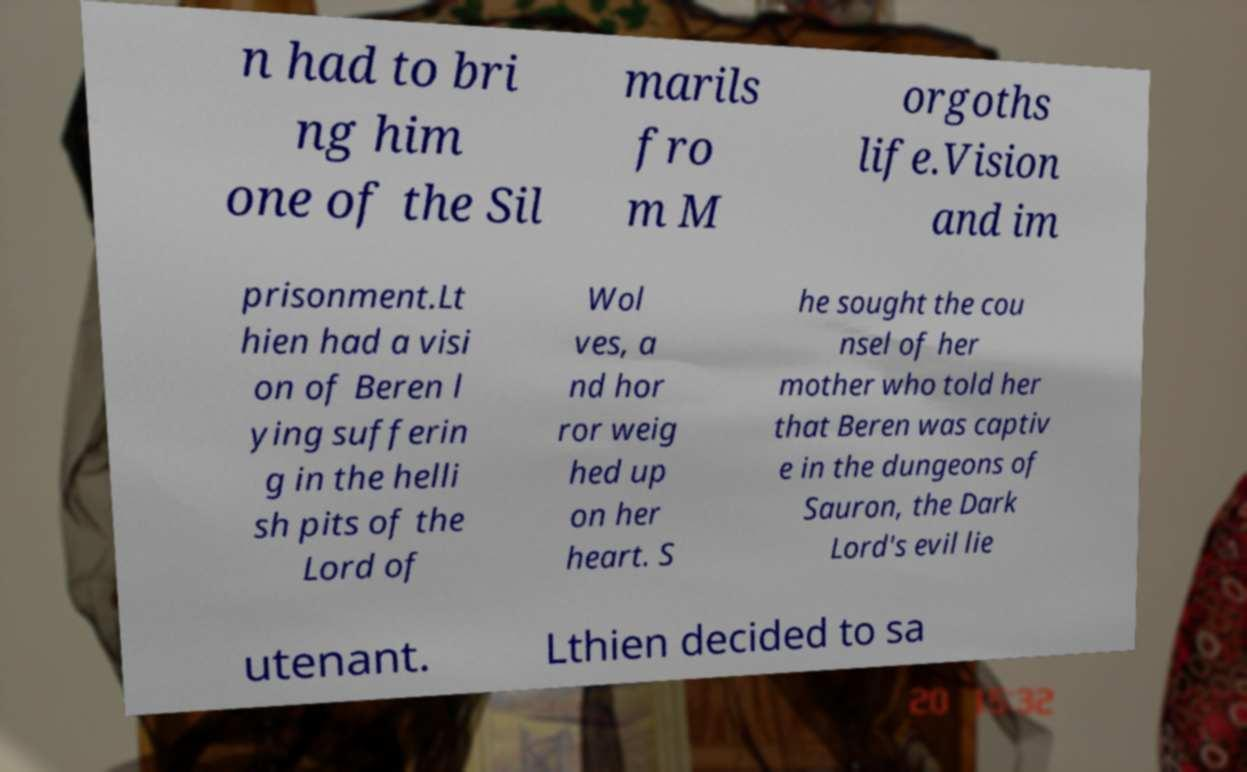Can you read and provide the text displayed in the image?This photo seems to have some interesting text. Can you extract and type it out for me? n had to bri ng him one of the Sil marils fro m M orgoths life.Vision and im prisonment.Lt hien had a visi on of Beren l ying sufferin g in the helli sh pits of the Lord of Wol ves, a nd hor ror weig hed up on her heart. S he sought the cou nsel of her mother who told her that Beren was captiv e in the dungeons of Sauron, the Dark Lord's evil lie utenant. Lthien decided to sa 